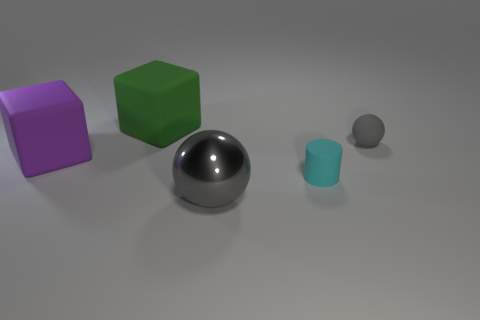Considering the arrangement of objects, what can you infer about spatial composition? The spatial composition shows a deliberate placement, with the large shiny ball at the center acting as a focal point. The blocks are staged at varying distances behind the ball, creating depth, while the tiny balls are positioned to the right, seemingly in a descending order of size, which might suggest a perspective or scaling effect. 